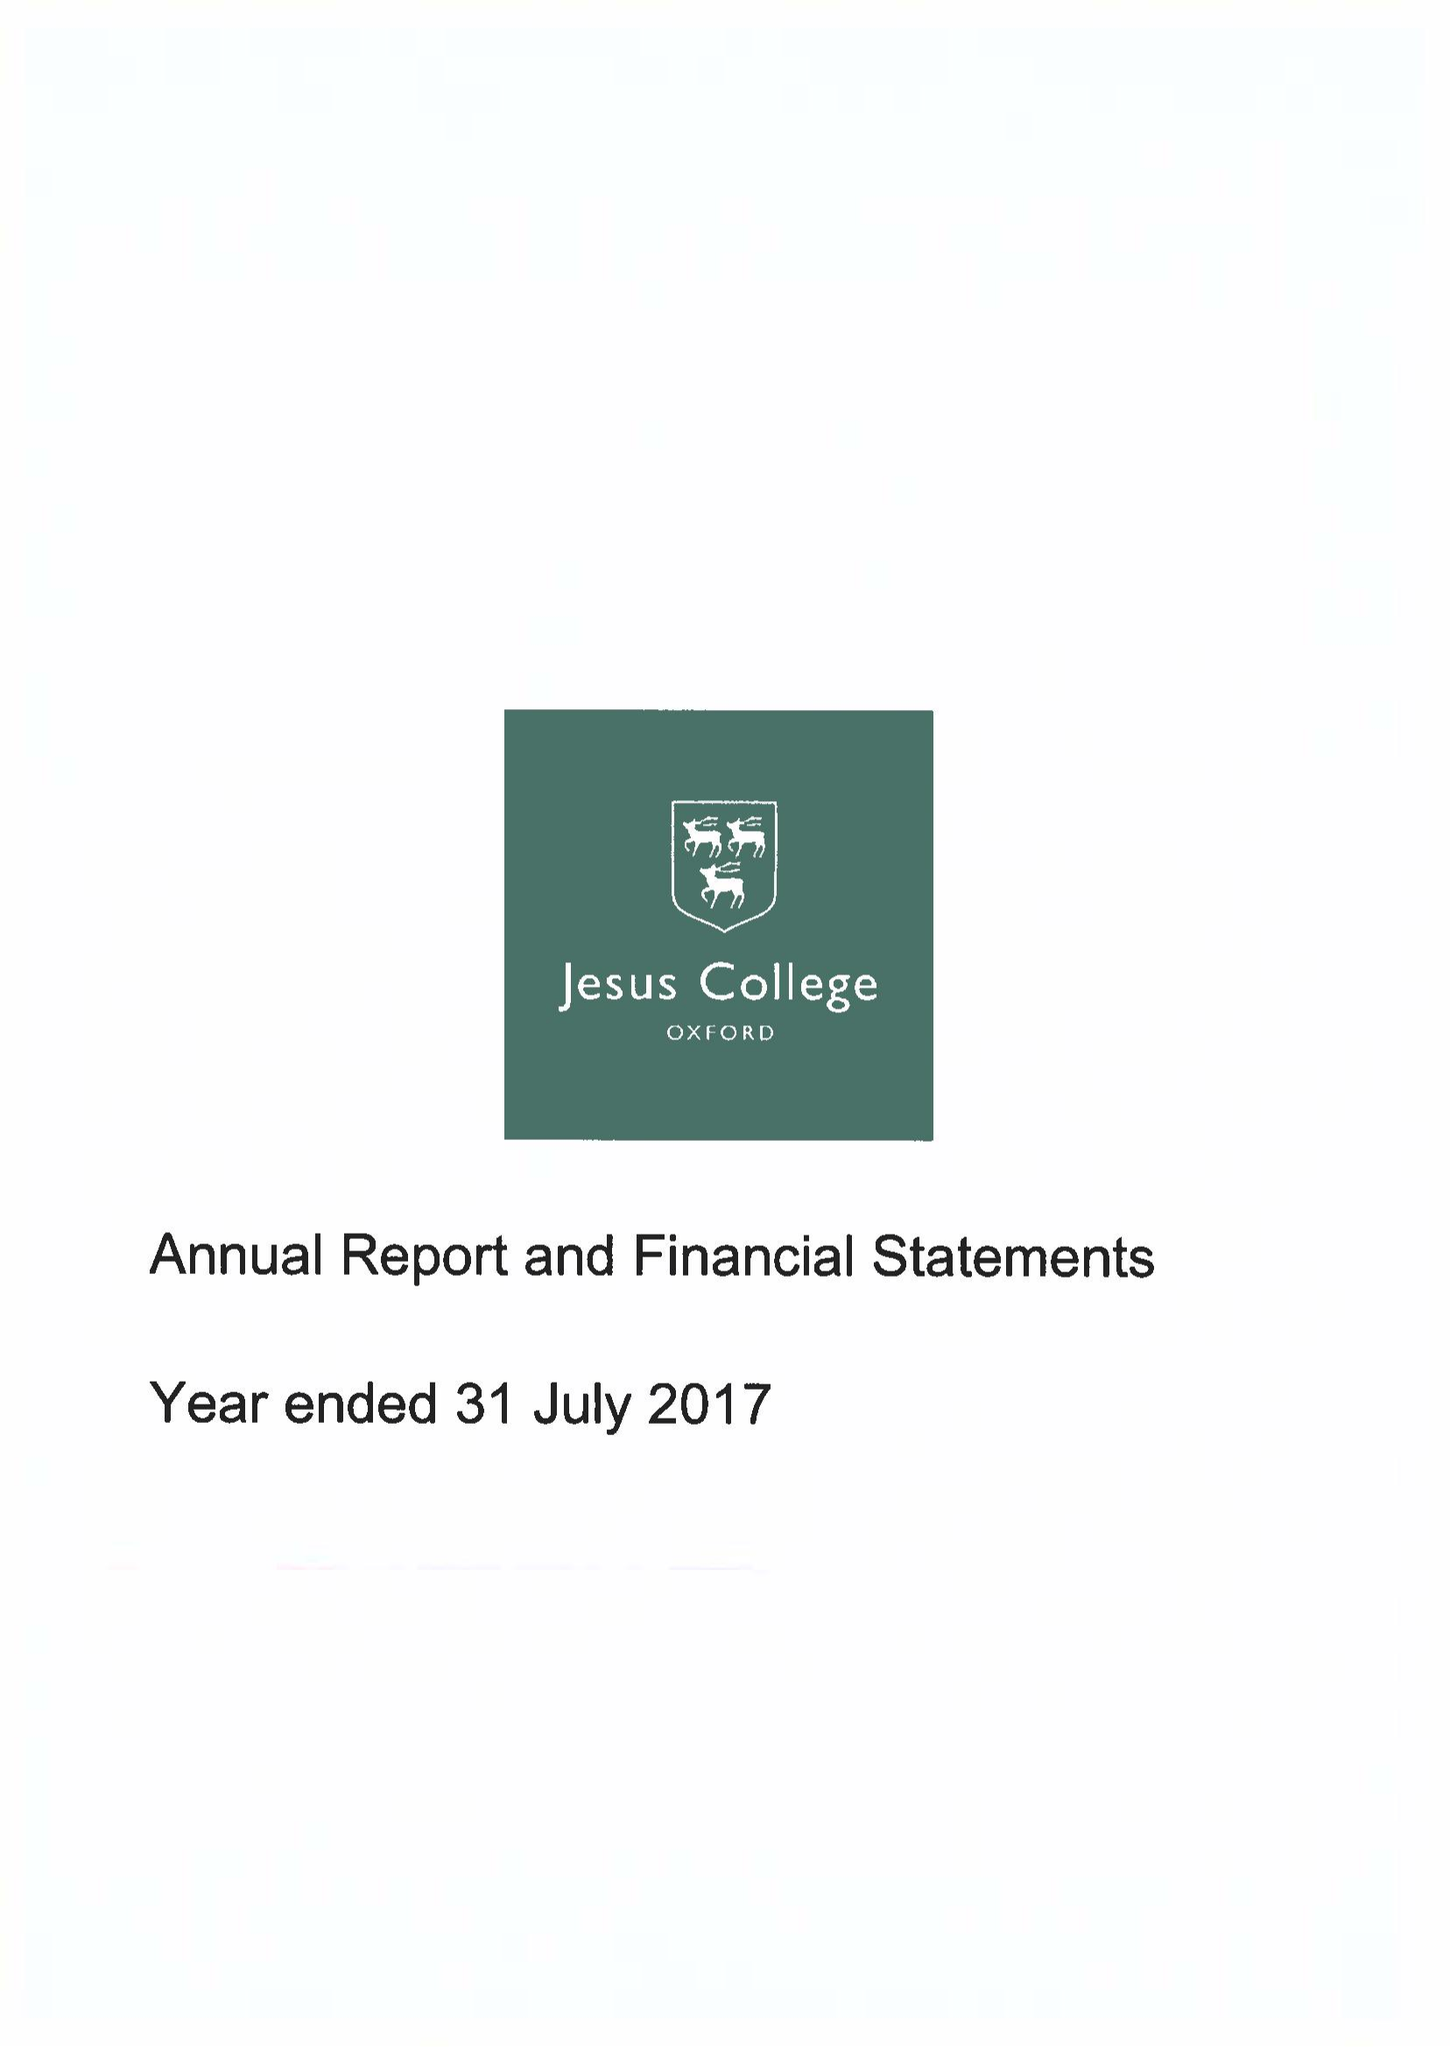What is the value for the address__post_town?
Answer the question using a single word or phrase. OXFORD 